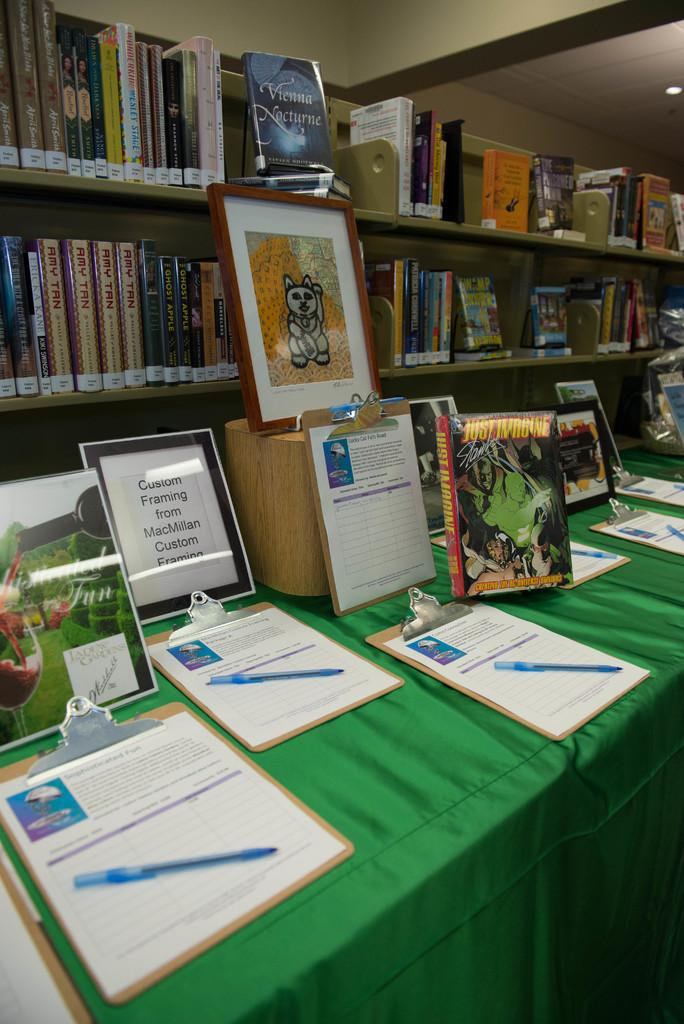<image>
Offer a succinct explanation of the picture presented. One of the books on display on the table is titled Just Imagine. 